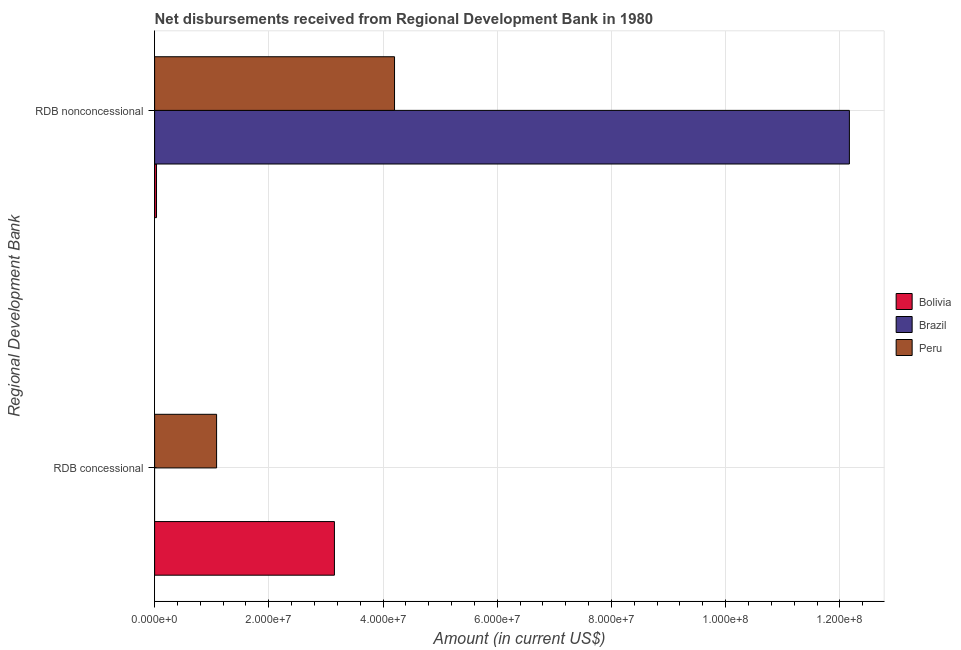Are the number of bars per tick equal to the number of legend labels?
Provide a short and direct response. No. What is the label of the 2nd group of bars from the top?
Provide a succinct answer. RDB concessional. What is the net concessional disbursements from rdb in Peru?
Your response must be concise. 1.09e+07. Across all countries, what is the maximum net concessional disbursements from rdb?
Give a very brief answer. 3.15e+07. Across all countries, what is the minimum net concessional disbursements from rdb?
Your response must be concise. 0. What is the total net non concessional disbursements from rdb in the graph?
Offer a terse response. 1.64e+08. What is the difference between the net concessional disbursements from rdb in Bolivia and that in Peru?
Ensure brevity in your answer.  2.06e+07. What is the difference between the net non concessional disbursements from rdb in Peru and the net concessional disbursements from rdb in Brazil?
Ensure brevity in your answer.  4.20e+07. What is the average net non concessional disbursements from rdb per country?
Your answer should be compact. 5.47e+07. What is the difference between the net concessional disbursements from rdb and net non concessional disbursements from rdb in Peru?
Provide a short and direct response. -3.12e+07. What is the ratio of the net non concessional disbursements from rdb in Peru to that in Bolivia?
Keep it short and to the point. 125.79. In how many countries, is the net non concessional disbursements from rdb greater than the average net non concessional disbursements from rdb taken over all countries?
Provide a short and direct response. 1. How many bars are there?
Provide a succinct answer. 5. Are all the bars in the graph horizontal?
Keep it short and to the point. Yes. What is the difference between two consecutive major ticks on the X-axis?
Offer a terse response. 2.00e+07. Are the values on the major ticks of X-axis written in scientific E-notation?
Make the answer very short. Yes. Does the graph contain grids?
Your answer should be compact. Yes. Where does the legend appear in the graph?
Offer a terse response. Center right. What is the title of the graph?
Give a very brief answer. Net disbursements received from Regional Development Bank in 1980. Does "European Union" appear as one of the legend labels in the graph?
Your answer should be very brief. No. What is the label or title of the X-axis?
Keep it short and to the point. Amount (in current US$). What is the label or title of the Y-axis?
Offer a very short reply. Regional Development Bank. What is the Amount (in current US$) in Bolivia in RDB concessional?
Your answer should be very brief. 3.15e+07. What is the Amount (in current US$) of Brazil in RDB concessional?
Provide a succinct answer. 0. What is the Amount (in current US$) in Peru in RDB concessional?
Make the answer very short. 1.09e+07. What is the Amount (in current US$) of Bolivia in RDB nonconcessional?
Keep it short and to the point. 3.34e+05. What is the Amount (in current US$) in Brazil in RDB nonconcessional?
Provide a succinct answer. 1.22e+08. What is the Amount (in current US$) of Peru in RDB nonconcessional?
Make the answer very short. 4.20e+07. Across all Regional Development Bank, what is the maximum Amount (in current US$) of Bolivia?
Offer a very short reply. 3.15e+07. Across all Regional Development Bank, what is the maximum Amount (in current US$) in Brazil?
Ensure brevity in your answer.  1.22e+08. Across all Regional Development Bank, what is the maximum Amount (in current US$) of Peru?
Your answer should be compact. 4.20e+07. Across all Regional Development Bank, what is the minimum Amount (in current US$) of Bolivia?
Provide a succinct answer. 3.34e+05. Across all Regional Development Bank, what is the minimum Amount (in current US$) of Brazil?
Offer a very short reply. 0. Across all Regional Development Bank, what is the minimum Amount (in current US$) of Peru?
Provide a succinct answer. 1.09e+07. What is the total Amount (in current US$) in Bolivia in the graph?
Provide a succinct answer. 3.18e+07. What is the total Amount (in current US$) of Brazil in the graph?
Provide a succinct answer. 1.22e+08. What is the total Amount (in current US$) of Peru in the graph?
Provide a succinct answer. 5.29e+07. What is the difference between the Amount (in current US$) in Bolivia in RDB concessional and that in RDB nonconcessional?
Your answer should be compact. 3.12e+07. What is the difference between the Amount (in current US$) in Peru in RDB concessional and that in RDB nonconcessional?
Your answer should be compact. -3.12e+07. What is the difference between the Amount (in current US$) of Bolivia in RDB concessional and the Amount (in current US$) of Brazil in RDB nonconcessional?
Your response must be concise. -9.02e+07. What is the difference between the Amount (in current US$) in Bolivia in RDB concessional and the Amount (in current US$) in Peru in RDB nonconcessional?
Provide a succinct answer. -1.05e+07. What is the average Amount (in current US$) in Bolivia per Regional Development Bank?
Provide a short and direct response. 1.59e+07. What is the average Amount (in current US$) in Brazil per Regional Development Bank?
Offer a very short reply. 6.08e+07. What is the average Amount (in current US$) in Peru per Regional Development Bank?
Ensure brevity in your answer.  2.64e+07. What is the difference between the Amount (in current US$) in Bolivia and Amount (in current US$) in Peru in RDB concessional?
Give a very brief answer. 2.06e+07. What is the difference between the Amount (in current US$) of Bolivia and Amount (in current US$) of Brazil in RDB nonconcessional?
Provide a short and direct response. -1.21e+08. What is the difference between the Amount (in current US$) of Bolivia and Amount (in current US$) of Peru in RDB nonconcessional?
Your answer should be very brief. -4.17e+07. What is the difference between the Amount (in current US$) of Brazil and Amount (in current US$) of Peru in RDB nonconcessional?
Make the answer very short. 7.97e+07. What is the ratio of the Amount (in current US$) of Bolivia in RDB concessional to that in RDB nonconcessional?
Offer a terse response. 94.27. What is the ratio of the Amount (in current US$) of Peru in RDB concessional to that in RDB nonconcessional?
Your answer should be very brief. 0.26. What is the difference between the highest and the second highest Amount (in current US$) of Bolivia?
Make the answer very short. 3.12e+07. What is the difference between the highest and the second highest Amount (in current US$) of Peru?
Provide a succinct answer. 3.12e+07. What is the difference between the highest and the lowest Amount (in current US$) of Bolivia?
Give a very brief answer. 3.12e+07. What is the difference between the highest and the lowest Amount (in current US$) in Brazil?
Offer a very short reply. 1.22e+08. What is the difference between the highest and the lowest Amount (in current US$) in Peru?
Provide a short and direct response. 3.12e+07. 